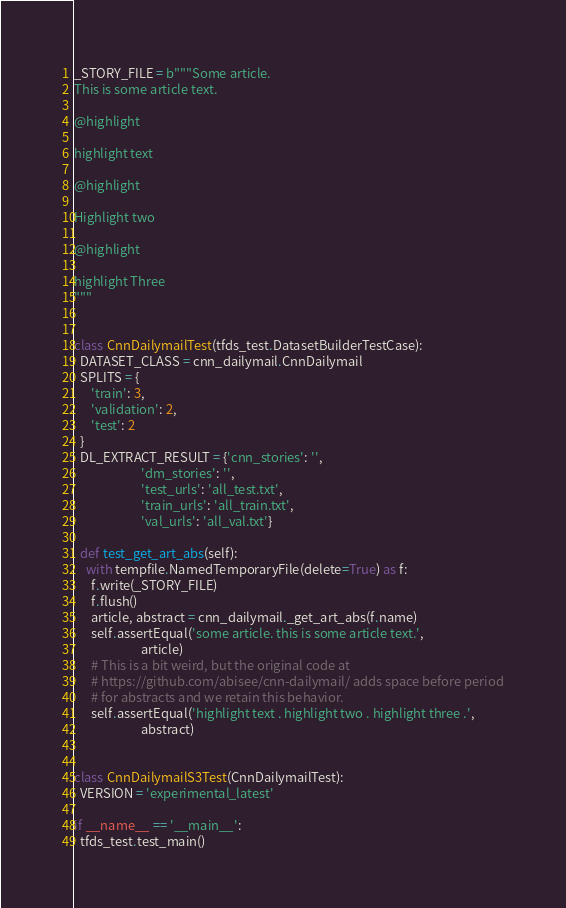<code> <loc_0><loc_0><loc_500><loc_500><_Python_>

_STORY_FILE = b"""Some article.
This is some article text.

@highlight

highlight text

@highlight

Highlight two

@highlight

highlight Three
"""


class CnnDailymailTest(tfds_test.DatasetBuilderTestCase):
  DATASET_CLASS = cnn_dailymail.CnnDailymail
  SPLITS = {
      'train': 3,
      'validation': 2,
      'test': 2
  }
  DL_EXTRACT_RESULT = {'cnn_stories': '',
                       'dm_stories': '',
                       'test_urls': 'all_test.txt',
                       'train_urls': 'all_train.txt',
                       'val_urls': 'all_val.txt'}

  def test_get_art_abs(self):
    with tempfile.NamedTemporaryFile(delete=True) as f:
      f.write(_STORY_FILE)
      f.flush()
      article, abstract = cnn_dailymail._get_art_abs(f.name)
      self.assertEqual('some article. this is some article text.',
                       article)
      # This is a bit weird, but the original code at
      # https://github.com/abisee/cnn-dailymail/ adds space before period
      # for abstracts and we retain this behavior.
      self.assertEqual('highlight text . highlight two . highlight three .',
                       abstract)


class CnnDailymailS3Test(CnnDailymailTest):
  VERSION = 'experimental_latest'

if __name__ == '__main__':
  tfds_test.test_main()
</code> 